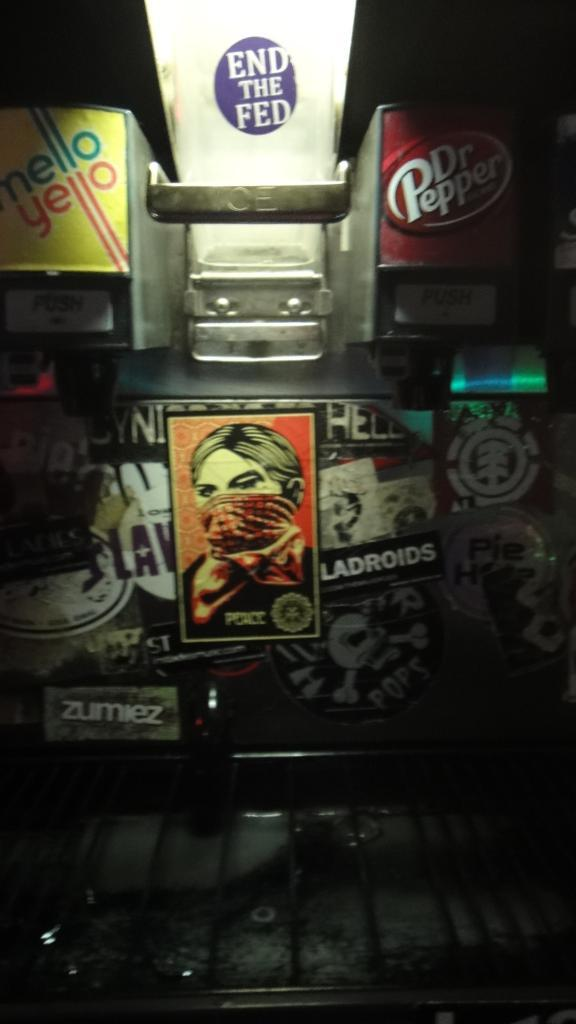<image>
Offer a succinct explanation of the picture presented. A fountain drink dispenser with stickers calling to End the Fed and a character wearing a bandana labeled police. 